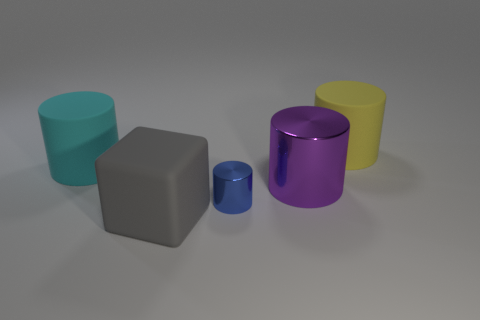Subtract 1 cylinders. How many cylinders are left? 3 Add 5 tiny red things. How many objects exist? 10 Subtract all blocks. How many objects are left? 4 Add 2 rubber things. How many rubber things exist? 5 Subtract 0 brown cylinders. How many objects are left? 5 Subtract all tiny gray matte cylinders. Subtract all big metal cylinders. How many objects are left? 4 Add 1 blue metallic cylinders. How many blue metallic cylinders are left? 2 